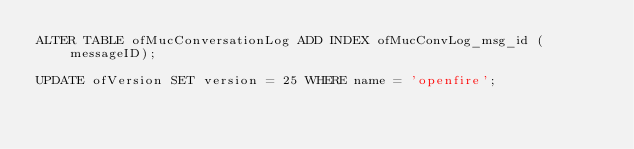<code> <loc_0><loc_0><loc_500><loc_500><_SQL_>ALTER TABLE ofMucConversationLog ADD INDEX ofMucConvLog_msg_id (messageID);

UPDATE ofVersion SET version = 25 WHERE name = 'openfire';
</code> 